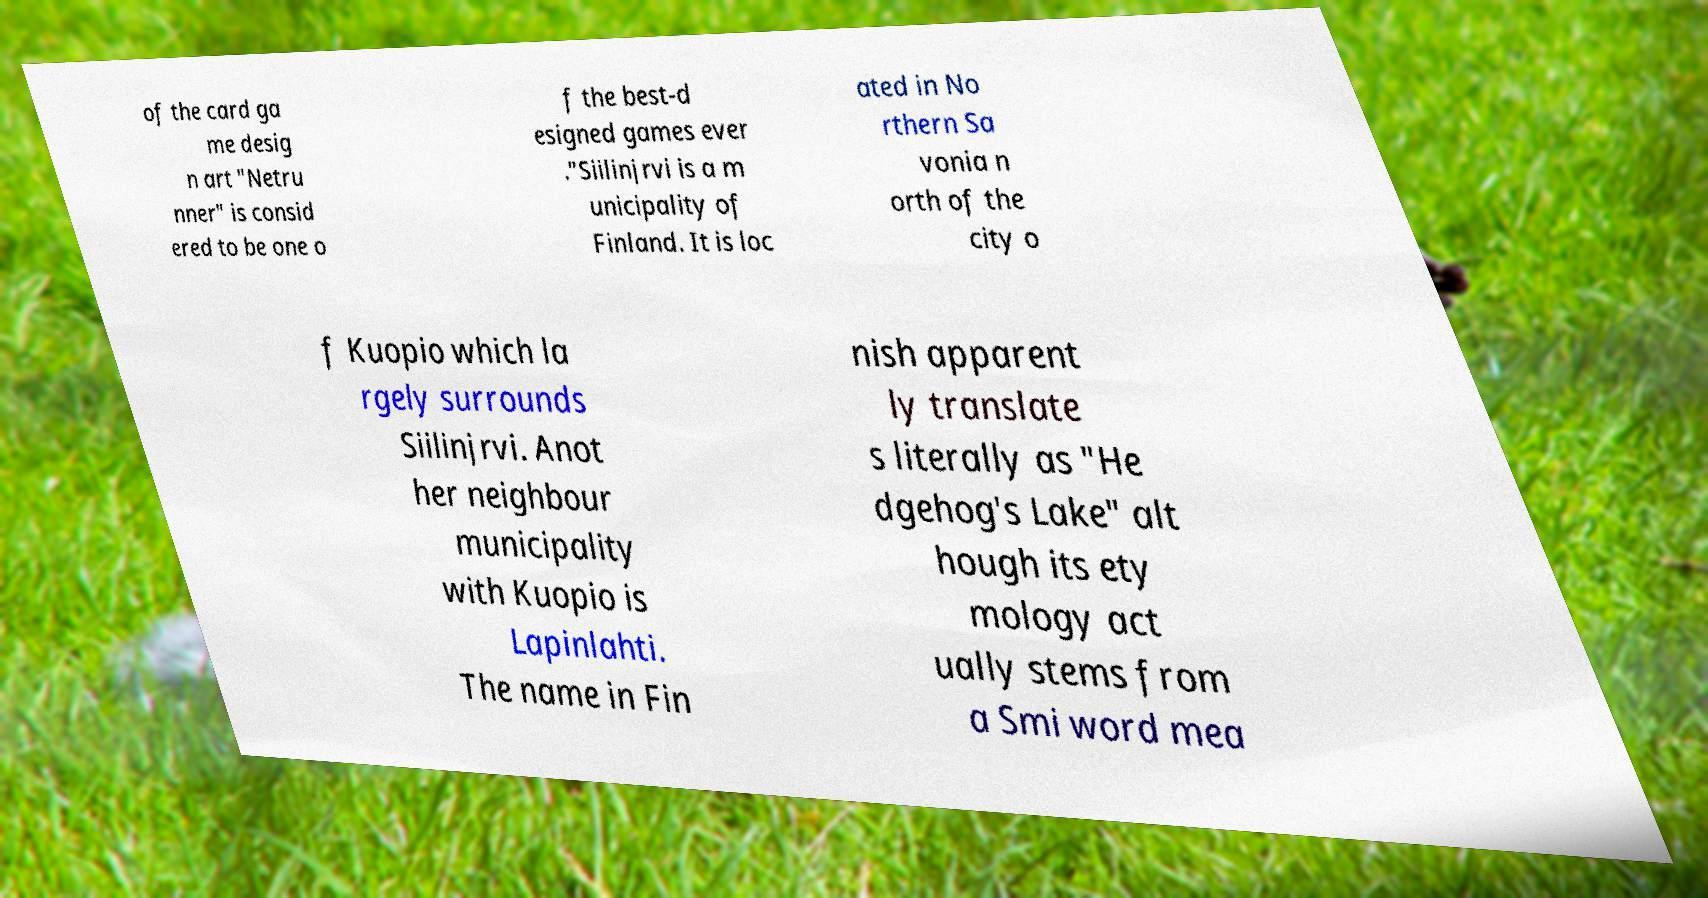There's text embedded in this image that I need extracted. Can you transcribe it verbatim? of the card ga me desig n art "Netru nner" is consid ered to be one o f the best-d esigned games ever ."Siilinjrvi is a m unicipality of Finland. It is loc ated in No rthern Sa vonia n orth of the city o f Kuopio which la rgely surrounds Siilinjrvi. Anot her neighbour municipality with Kuopio is Lapinlahti. The name in Fin nish apparent ly translate s literally as "He dgehog's Lake" alt hough its ety mology act ually stems from a Smi word mea 